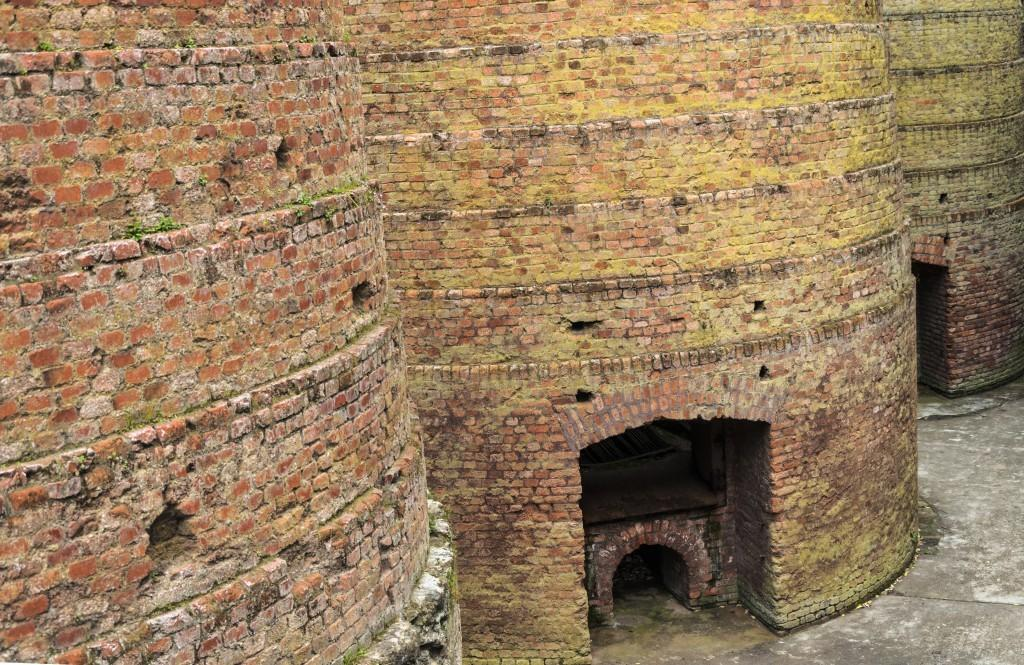What type of structure is visible in the image? The image contains a brick wall. Is there any path or way visible in the image? Yes, there is a path or way in the center at the bottom of the image. How many eggs are being cooked on the camp stove in the image? There is no camp stove or eggs present in the image. 